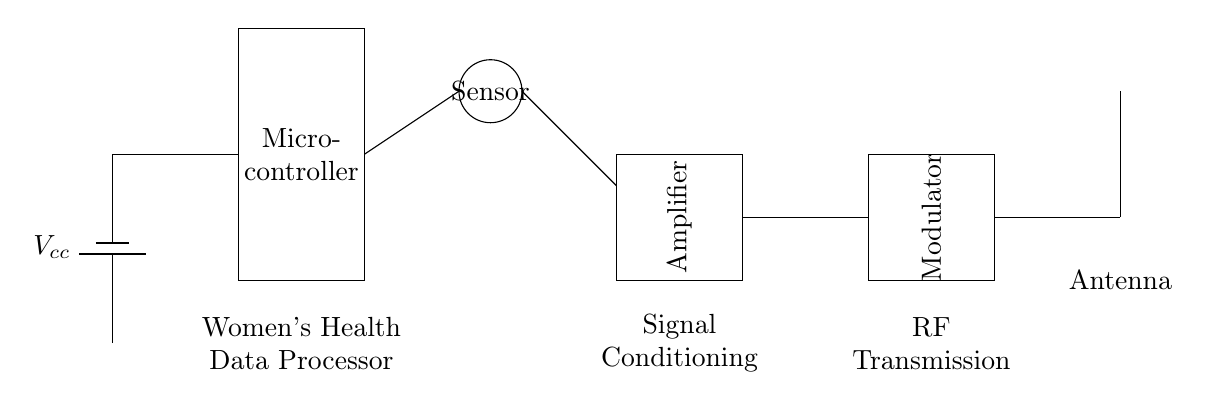What is the primary function of the microcontroller in this circuit? The microcontroller processes women's health data and controls the circuit operations by coordinating signals and managing the interaction between components like the sensor and the modulator.
Answer: Process data What component amplifies the signal in this circuit? The circuit includes an amplifier, which is specifically designed to increase the power, voltage, or current of the signal coming from the sensor before transmitting it.
Answer: Amplifier What does the antenna do in this circuit? The antenna converts the modulated RF signals into electromagnetic waves for transmission, facilitating wireless communication of the health data.
Answer: Transmission Which component connects to the power supply? The circuit shows that the microcontroller is directly connected to the power supply, as indicated by the line leading from the battery to the microcontroller.
Answer: Microcontroller How many main components are shown in this circuit? The circuit depicts five main components: the power supply, microcontroller, sensor, amplifier, and modulator, leading down to the antenna.
Answer: Five What does the modulator do with the signal? The modulator processes and modifies the signal from the amplifier, preparing it for transmission through the antenna by encoding the data onto a carrier wave.
Answer: Encodes data What type of device is this circuit designed for? This circuit is specifically designed as a compact RF transmitter for wearable devices focused on women's health data tracking, indicating its application in health monitoring.
Answer: Wearable device 